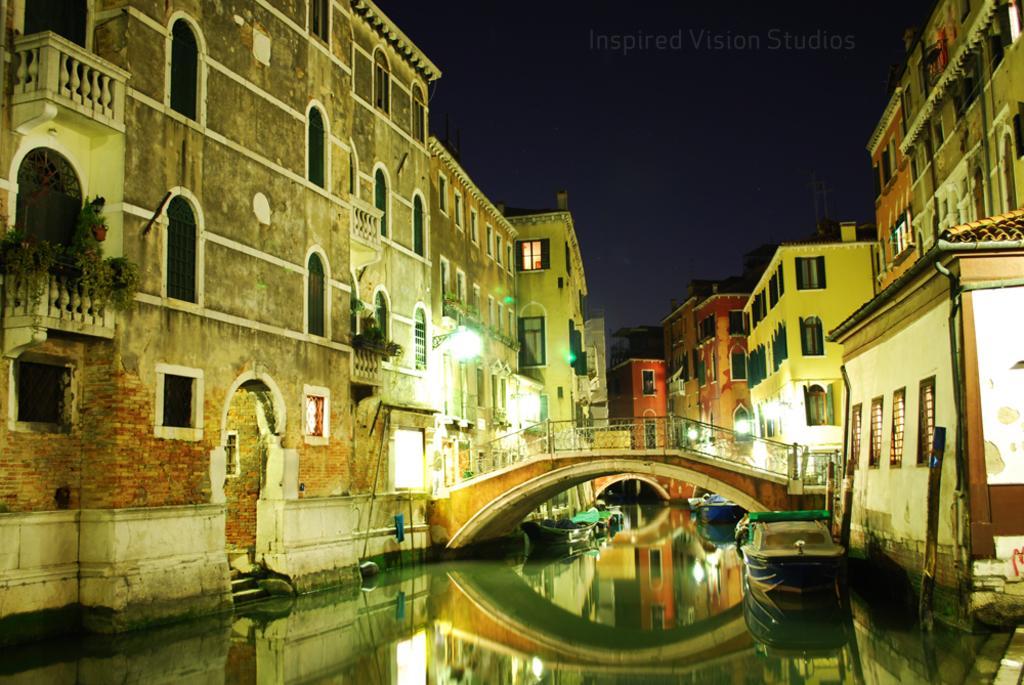Please provide a concise description of this image. In this image we can see boats on the surface of water. In the background, bridge and buildings are there. There is the sky at the top of the image. 